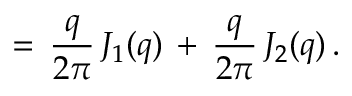Convert formula to latex. <formula><loc_0><loc_0><loc_500><loc_500>= \, \frac { q } { 2 \pi } \, J _ { 1 } ( q ) \, + \, \frac { q } { 2 \pi } \, J _ { 2 } ( q ) \, { . }</formula> 